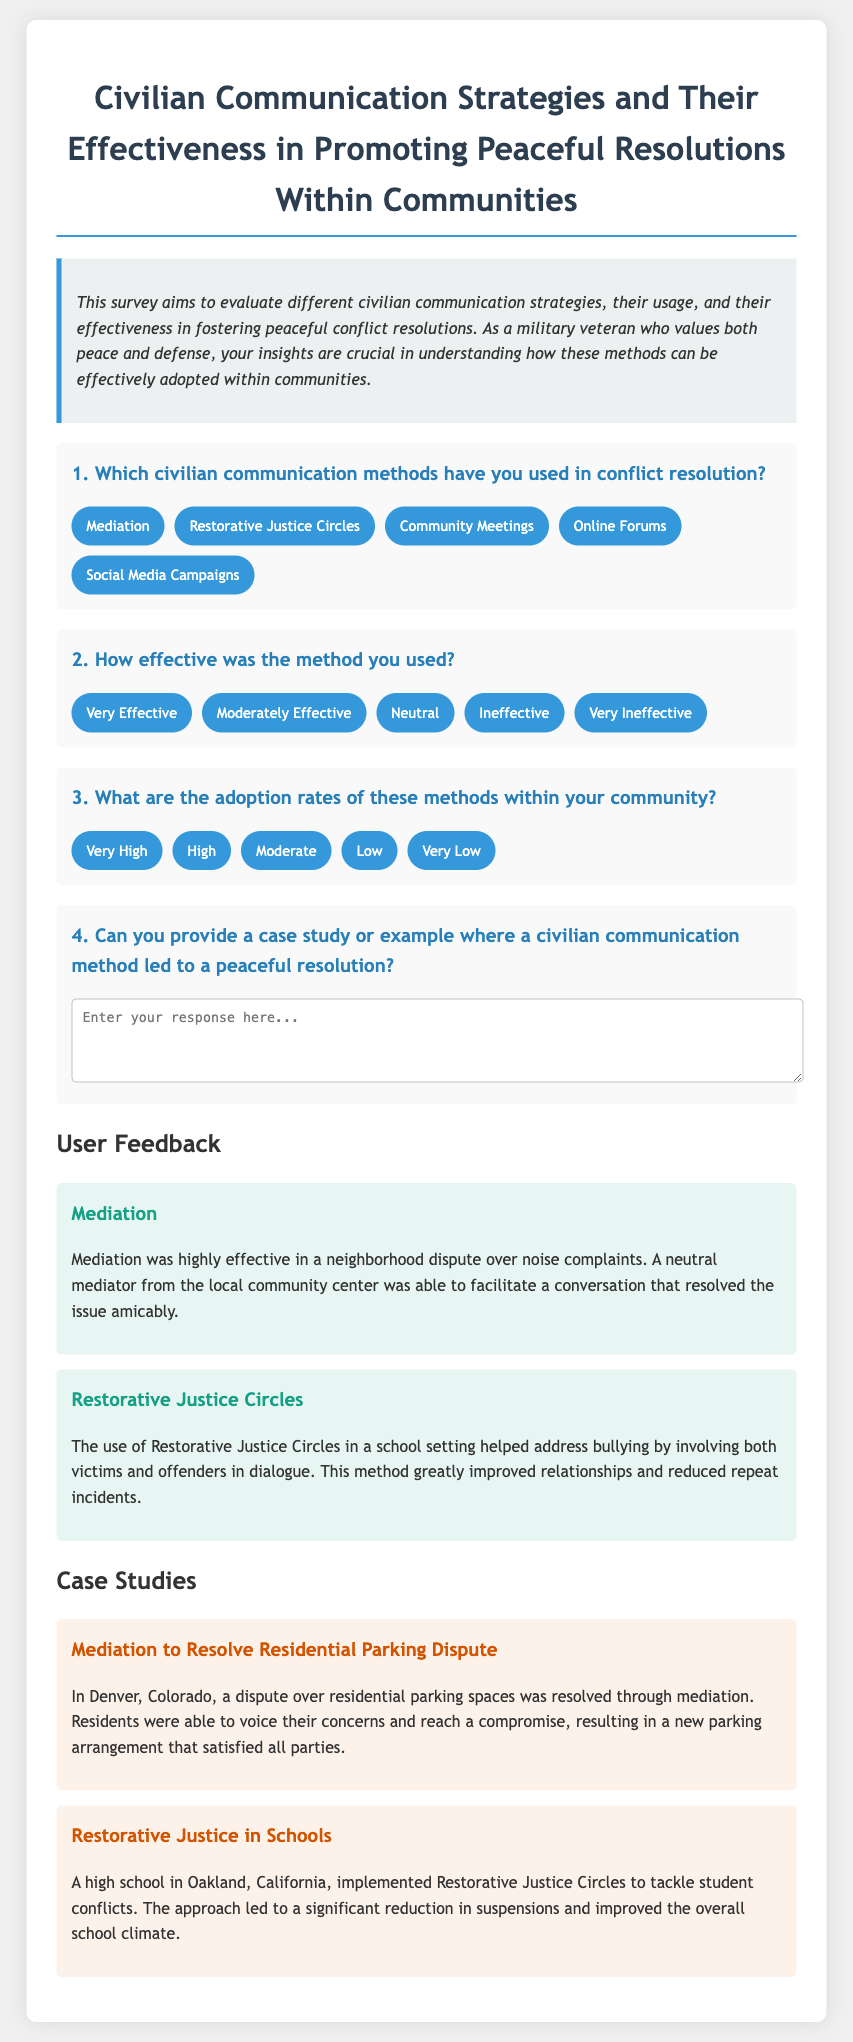Which civilian communication methods are mentioned? The document lists multiple communication methods for conflict resolution including Mediation, Restorative Justice Circles, Community Meetings, Online Forums, and Social Media Campaigns.
Answer: Mediation, Restorative Justice Circles, Community Meetings, Online Forums, Social Media Campaigns How effective was mediation according to the feedback? The feedback states that mediation was highly effective in resolving a neighborhood dispute over noise complaints.
Answer: Highly effective What was the adoption rate of Restorative Justice Circles in the mentioned case study? The case study does not specifically state an adoption rate for Restorative Justice Circles, but it indicates significant success in reducing repeat incidents of bullying.
Answer: Not specifically mentioned What case study revolves around a parking dispute? The document includes a case study on a residential parking dispute resolved through mediation in Denver, Colorado.
Answer: Mediation to Resolve Residential Parking Dispute Which method helped reduce school suspensions? The impact of Restorative Justice Circles in a high school setting led to a significant reduction in suspensions.
Answer: Restorative Justice Circles 